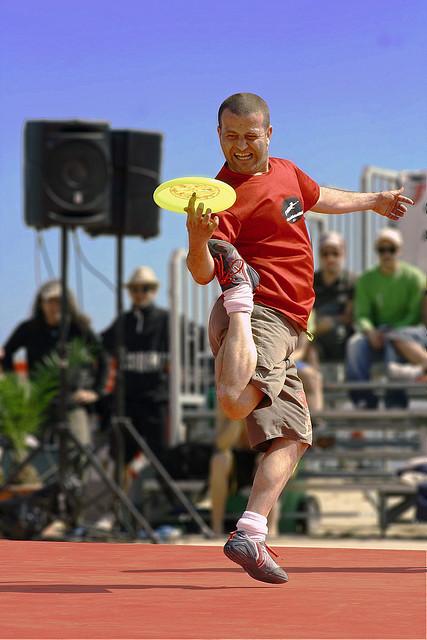How many people are in the background?
Short answer required. 4. What is the boy doing?
Concise answer only. Frisbee. What is the guy holding in his right hand?
Be succinct. Frisbee. What is the man playing?
Be succinct. Frisbee. Is this man wearing socks?
Answer briefly. Yes. Does this sport require grace and flexibility?
Answer briefly. Yes. What sport are they playing?
Give a very brief answer. Frisbee. What is this guy doing?
Short answer required. Playing frisbee. Is this man old?
Write a very short answer. No. What is the man holding?
Answer briefly. Frisbee. What color is the disc?
Concise answer only. Yellow. What sport is this?
Give a very brief answer. Frisbee. Is he wearing sunglasses?
Give a very brief answer. No. What color is the Frisbee?
Quick response, please. Yellow. Are the man's feet touching the ground?
Answer briefly. No. What letter repeats on the man's shirt?
Concise answer only. A. 